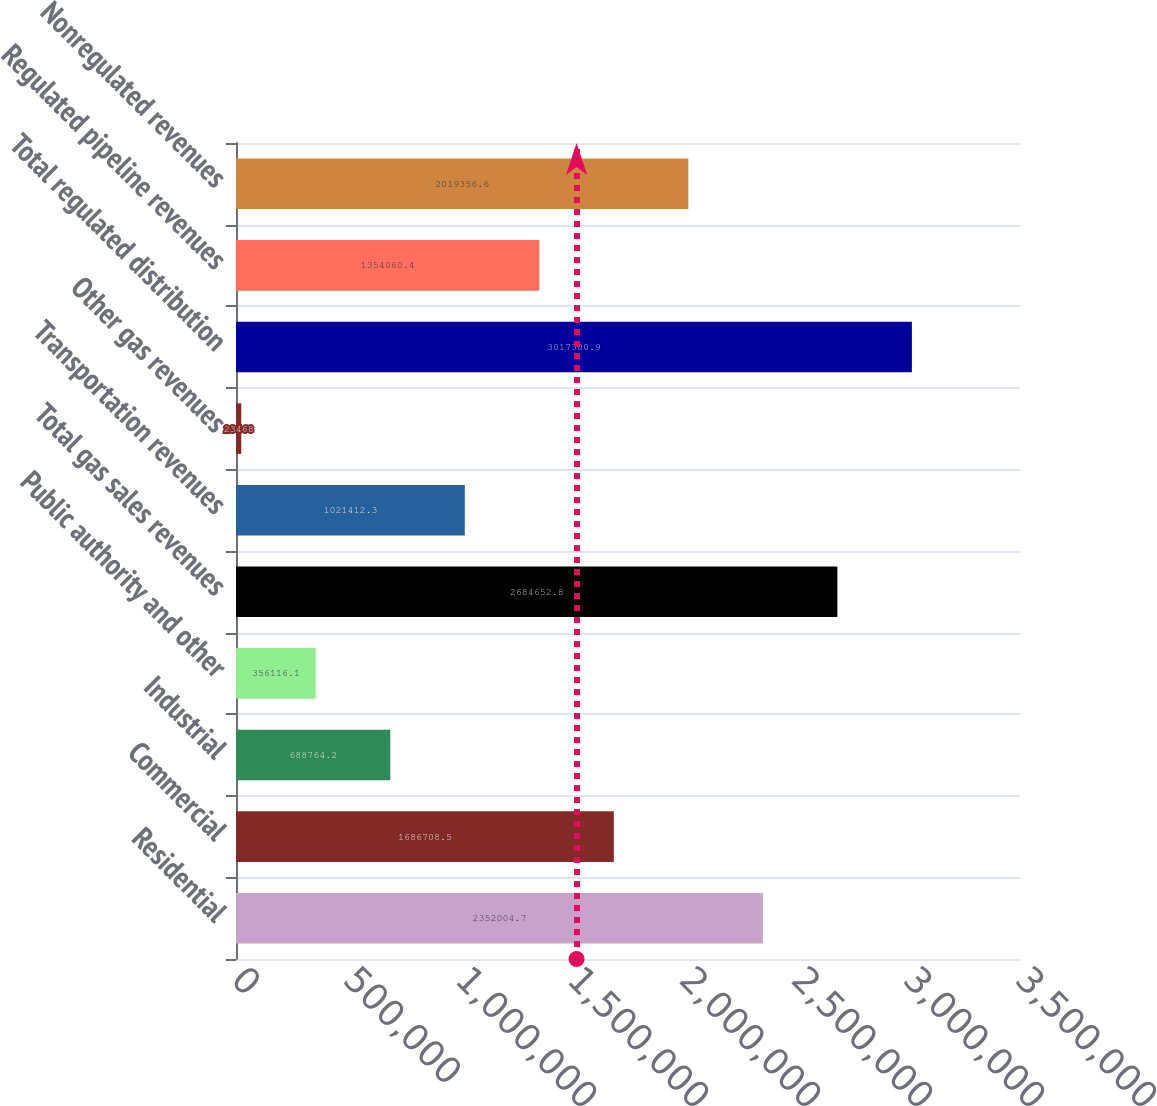<chart> <loc_0><loc_0><loc_500><loc_500><bar_chart><fcel>Residential<fcel>Commercial<fcel>Industrial<fcel>Public authority and other<fcel>Total gas sales revenues<fcel>Transportation revenues<fcel>Other gas revenues<fcel>Total regulated distribution<fcel>Regulated pipeline revenues<fcel>Nonregulated revenues<nl><fcel>2.352e+06<fcel>1.68671e+06<fcel>688764<fcel>356116<fcel>2.68465e+06<fcel>1.02141e+06<fcel>23468<fcel>3.0173e+06<fcel>1.35406e+06<fcel>2.01936e+06<nl></chart> 